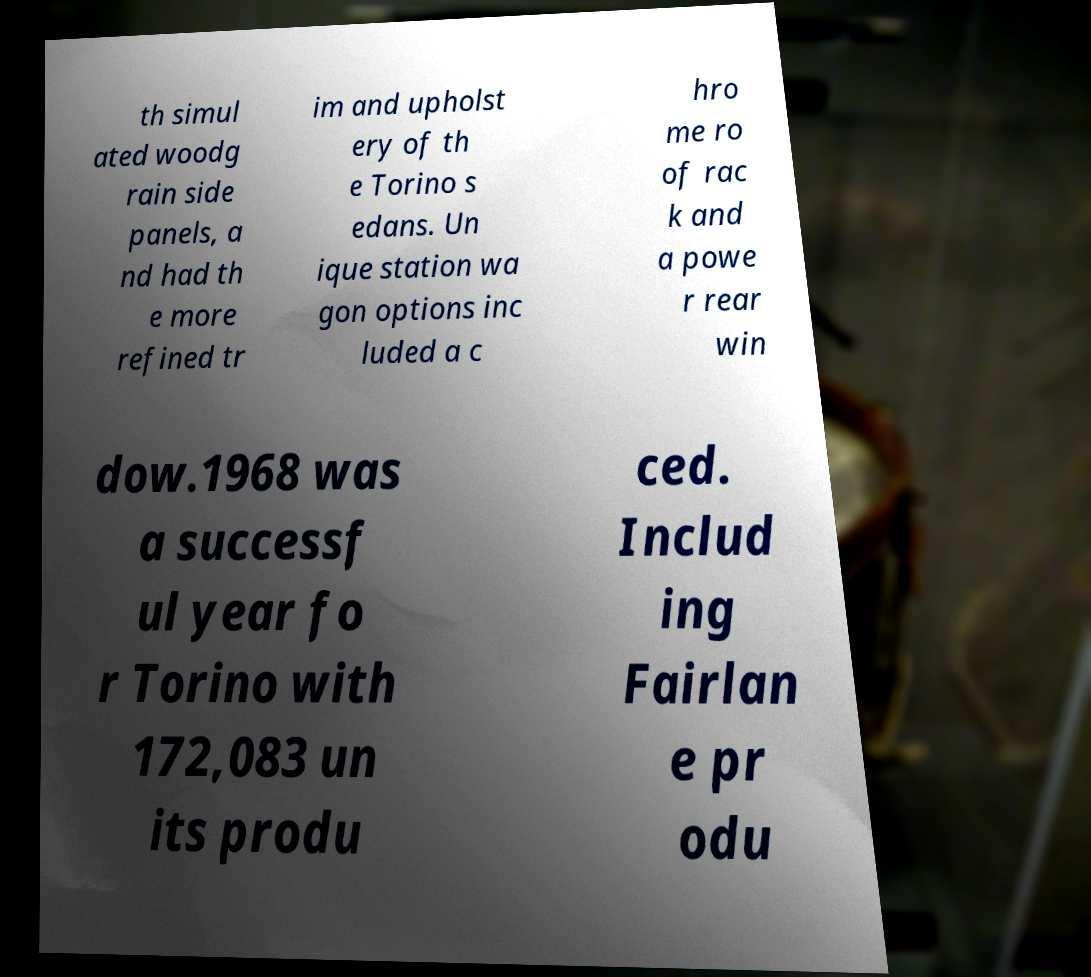Can you read and provide the text displayed in the image?This photo seems to have some interesting text. Can you extract and type it out for me? th simul ated woodg rain side panels, a nd had th e more refined tr im and upholst ery of th e Torino s edans. Un ique station wa gon options inc luded a c hro me ro of rac k and a powe r rear win dow.1968 was a successf ul year fo r Torino with 172,083 un its produ ced. Includ ing Fairlan e pr odu 